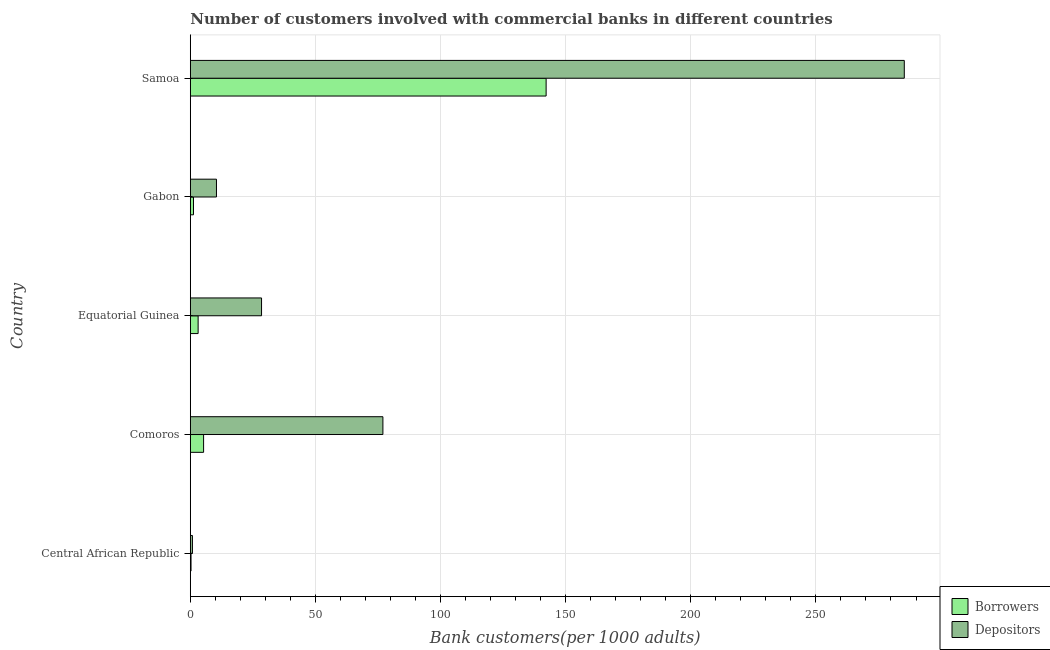Are the number of bars per tick equal to the number of legend labels?
Make the answer very short. Yes. Are the number of bars on each tick of the Y-axis equal?
Offer a very short reply. Yes. What is the label of the 1st group of bars from the top?
Give a very brief answer. Samoa. What is the number of depositors in Gabon?
Give a very brief answer. 10.46. Across all countries, what is the maximum number of borrowers?
Your response must be concise. 142.19. Across all countries, what is the minimum number of depositors?
Ensure brevity in your answer.  0.86. In which country was the number of depositors maximum?
Make the answer very short. Samoa. In which country was the number of depositors minimum?
Provide a short and direct response. Central African Republic. What is the total number of borrowers in the graph?
Offer a very short reply. 152.21. What is the difference between the number of borrowers in Central African Republic and that in Gabon?
Provide a succinct answer. -0.99. What is the difference between the number of borrowers in Central African Republic and the number of depositors in Gabon?
Ensure brevity in your answer.  -10.17. What is the average number of borrowers per country?
Provide a succinct answer. 30.44. What is the difference between the number of borrowers and number of depositors in Equatorial Guinea?
Ensure brevity in your answer.  -25.34. What is the difference between the highest and the second highest number of depositors?
Provide a short and direct response. 208.35. What is the difference between the highest and the lowest number of borrowers?
Give a very brief answer. 141.89. Is the sum of the number of depositors in Gabon and Samoa greater than the maximum number of borrowers across all countries?
Ensure brevity in your answer.  Yes. What does the 1st bar from the top in Comoros represents?
Provide a short and direct response. Depositors. What does the 2nd bar from the bottom in Gabon represents?
Give a very brief answer. Depositors. How many countries are there in the graph?
Keep it short and to the point. 5. What is the difference between two consecutive major ticks on the X-axis?
Offer a very short reply. 50. Are the values on the major ticks of X-axis written in scientific E-notation?
Keep it short and to the point. No. Does the graph contain any zero values?
Ensure brevity in your answer.  No. Where does the legend appear in the graph?
Make the answer very short. Bottom right. How are the legend labels stacked?
Make the answer very short. Vertical. What is the title of the graph?
Your response must be concise. Number of customers involved with commercial banks in different countries. What is the label or title of the X-axis?
Ensure brevity in your answer.  Bank customers(per 1000 adults). What is the label or title of the Y-axis?
Make the answer very short. Country. What is the Bank customers(per 1000 adults) in Borrowers in Central African Republic?
Give a very brief answer. 0.3. What is the Bank customers(per 1000 adults) of Depositors in Central African Republic?
Ensure brevity in your answer.  0.86. What is the Bank customers(per 1000 adults) of Borrowers in Comoros?
Offer a very short reply. 5.31. What is the Bank customers(per 1000 adults) in Depositors in Comoros?
Provide a short and direct response. 76.97. What is the Bank customers(per 1000 adults) in Borrowers in Equatorial Guinea?
Offer a terse response. 3.13. What is the Bank customers(per 1000 adults) in Depositors in Equatorial Guinea?
Ensure brevity in your answer.  28.47. What is the Bank customers(per 1000 adults) in Borrowers in Gabon?
Offer a terse response. 1.28. What is the Bank customers(per 1000 adults) of Depositors in Gabon?
Your answer should be very brief. 10.46. What is the Bank customers(per 1000 adults) of Borrowers in Samoa?
Your answer should be very brief. 142.19. What is the Bank customers(per 1000 adults) of Depositors in Samoa?
Your response must be concise. 285.32. Across all countries, what is the maximum Bank customers(per 1000 adults) of Borrowers?
Make the answer very short. 142.19. Across all countries, what is the maximum Bank customers(per 1000 adults) in Depositors?
Offer a terse response. 285.32. Across all countries, what is the minimum Bank customers(per 1000 adults) in Borrowers?
Offer a terse response. 0.3. Across all countries, what is the minimum Bank customers(per 1000 adults) in Depositors?
Your answer should be compact. 0.86. What is the total Bank customers(per 1000 adults) of Borrowers in the graph?
Your answer should be very brief. 152.21. What is the total Bank customers(per 1000 adults) of Depositors in the graph?
Provide a short and direct response. 402.08. What is the difference between the Bank customers(per 1000 adults) in Borrowers in Central African Republic and that in Comoros?
Offer a terse response. -5.02. What is the difference between the Bank customers(per 1000 adults) of Depositors in Central African Republic and that in Comoros?
Provide a succinct answer. -76.11. What is the difference between the Bank customers(per 1000 adults) of Borrowers in Central African Republic and that in Equatorial Guinea?
Provide a short and direct response. -2.84. What is the difference between the Bank customers(per 1000 adults) of Depositors in Central African Republic and that in Equatorial Guinea?
Provide a succinct answer. -27.62. What is the difference between the Bank customers(per 1000 adults) in Borrowers in Central African Republic and that in Gabon?
Your response must be concise. -0.99. What is the difference between the Bank customers(per 1000 adults) in Depositors in Central African Republic and that in Gabon?
Keep it short and to the point. -9.61. What is the difference between the Bank customers(per 1000 adults) of Borrowers in Central African Republic and that in Samoa?
Provide a short and direct response. -141.89. What is the difference between the Bank customers(per 1000 adults) in Depositors in Central African Republic and that in Samoa?
Offer a terse response. -284.46. What is the difference between the Bank customers(per 1000 adults) in Borrowers in Comoros and that in Equatorial Guinea?
Offer a terse response. 2.18. What is the difference between the Bank customers(per 1000 adults) of Depositors in Comoros and that in Equatorial Guinea?
Make the answer very short. 48.5. What is the difference between the Bank customers(per 1000 adults) in Borrowers in Comoros and that in Gabon?
Provide a short and direct response. 4.03. What is the difference between the Bank customers(per 1000 adults) in Depositors in Comoros and that in Gabon?
Your answer should be compact. 66.51. What is the difference between the Bank customers(per 1000 adults) of Borrowers in Comoros and that in Samoa?
Ensure brevity in your answer.  -136.88. What is the difference between the Bank customers(per 1000 adults) in Depositors in Comoros and that in Samoa?
Your answer should be very brief. -208.35. What is the difference between the Bank customers(per 1000 adults) in Borrowers in Equatorial Guinea and that in Gabon?
Your response must be concise. 1.85. What is the difference between the Bank customers(per 1000 adults) of Depositors in Equatorial Guinea and that in Gabon?
Keep it short and to the point. 18.01. What is the difference between the Bank customers(per 1000 adults) in Borrowers in Equatorial Guinea and that in Samoa?
Provide a succinct answer. -139.06. What is the difference between the Bank customers(per 1000 adults) in Depositors in Equatorial Guinea and that in Samoa?
Make the answer very short. -256.85. What is the difference between the Bank customers(per 1000 adults) in Borrowers in Gabon and that in Samoa?
Keep it short and to the point. -140.91. What is the difference between the Bank customers(per 1000 adults) of Depositors in Gabon and that in Samoa?
Your response must be concise. -274.86. What is the difference between the Bank customers(per 1000 adults) in Borrowers in Central African Republic and the Bank customers(per 1000 adults) in Depositors in Comoros?
Provide a short and direct response. -76.68. What is the difference between the Bank customers(per 1000 adults) in Borrowers in Central African Republic and the Bank customers(per 1000 adults) in Depositors in Equatorial Guinea?
Offer a terse response. -28.18. What is the difference between the Bank customers(per 1000 adults) of Borrowers in Central African Republic and the Bank customers(per 1000 adults) of Depositors in Gabon?
Offer a very short reply. -10.17. What is the difference between the Bank customers(per 1000 adults) in Borrowers in Central African Republic and the Bank customers(per 1000 adults) in Depositors in Samoa?
Keep it short and to the point. -285.02. What is the difference between the Bank customers(per 1000 adults) in Borrowers in Comoros and the Bank customers(per 1000 adults) in Depositors in Equatorial Guinea?
Make the answer very short. -23.16. What is the difference between the Bank customers(per 1000 adults) of Borrowers in Comoros and the Bank customers(per 1000 adults) of Depositors in Gabon?
Offer a terse response. -5.15. What is the difference between the Bank customers(per 1000 adults) of Borrowers in Comoros and the Bank customers(per 1000 adults) of Depositors in Samoa?
Provide a short and direct response. -280.01. What is the difference between the Bank customers(per 1000 adults) of Borrowers in Equatorial Guinea and the Bank customers(per 1000 adults) of Depositors in Gabon?
Ensure brevity in your answer.  -7.33. What is the difference between the Bank customers(per 1000 adults) of Borrowers in Equatorial Guinea and the Bank customers(per 1000 adults) of Depositors in Samoa?
Your answer should be compact. -282.19. What is the difference between the Bank customers(per 1000 adults) of Borrowers in Gabon and the Bank customers(per 1000 adults) of Depositors in Samoa?
Offer a terse response. -284.04. What is the average Bank customers(per 1000 adults) in Borrowers per country?
Your answer should be very brief. 30.44. What is the average Bank customers(per 1000 adults) of Depositors per country?
Offer a very short reply. 80.42. What is the difference between the Bank customers(per 1000 adults) in Borrowers and Bank customers(per 1000 adults) in Depositors in Central African Republic?
Make the answer very short. -0.56. What is the difference between the Bank customers(per 1000 adults) of Borrowers and Bank customers(per 1000 adults) of Depositors in Comoros?
Provide a short and direct response. -71.66. What is the difference between the Bank customers(per 1000 adults) in Borrowers and Bank customers(per 1000 adults) in Depositors in Equatorial Guinea?
Your answer should be very brief. -25.34. What is the difference between the Bank customers(per 1000 adults) in Borrowers and Bank customers(per 1000 adults) in Depositors in Gabon?
Make the answer very short. -9.18. What is the difference between the Bank customers(per 1000 adults) of Borrowers and Bank customers(per 1000 adults) of Depositors in Samoa?
Offer a very short reply. -143.13. What is the ratio of the Bank customers(per 1000 adults) of Borrowers in Central African Republic to that in Comoros?
Provide a short and direct response. 0.06. What is the ratio of the Bank customers(per 1000 adults) in Depositors in Central African Republic to that in Comoros?
Give a very brief answer. 0.01. What is the ratio of the Bank customers(per 1000 adults) in Borrowers in Central African Republic to that in Equatorial Guinea?
Give a very brief answer. 0.09. What is the ratio of the Bank customers(per 1000 adults) in Depositors in Central African Republic to that in Equatorial Guinea?
Provide a succinct answer. 0.03. What is the ratio of the Bank customers(per 1000 adults) in Borrowers in Central African Republic to that in Gabon?
Your answer should be very brief. 0.23. What is the ratio of the Bank customers(per 1000 adults) in Depositors in Central African Republic to that in Gabon?
Provide a succinct answer. 0.08. What is the ratio of the Bank customers(per 1000 adults) of Borrowers in Central African Republic to that in Samoa?
Offer a terse response. 0. What is the ratio of the Bank customers(per 1000 adults) in Depositors in Central African Republic to that in Samoa?
Give a very brief answer. 0. What is the ratio of the Bank customers(per 1000 adults) of Borrowers in Comoros to that in Equatorial Guinea?
Offer a very short reply. 1.7. What is the ratio of the Bank customers(per 1000 adults) of Depositors in Comoros to that in Equatorial Guinea?
Your answer should be compact. 2.7. What is the ratio of the Bank customers(per 1000 adults) in Borrowers in Comoros to that in Gabon?
Your answer should be compact. 4.14. What is the ratio of the Bank customers(per 1000 adults) of Depositors in Comoros to that in Gabon?
Ensure brevity in your answer.  7.36. What is the ratio of the Bank customers(per 1000 adults) of Borrowers in Comoros to that in Samoa?
Your answer should be very brief. 0.04. What is the ratio of the Bank customers(per 1000 adults) of Depositors in Comoros to that in Samoa?
Keep it short and to the point. 0.27. What is the ratio of the Bank customers(per 1000 adults) in Borrowers in Equatorial Guinea to that in Gabon?
Your response must be concise. 2.44. What is the ratio of the Bank customers(per 1000 adults) of Depositors in Equatorial Guinea to that in Gabon?
Offer a terse response. 2.72. What is the ratio of the Bank customers(per 1000 adults) of Borrowers in Equatorial Guinea to that in Samoa?
Provide a short and direct response. 0.02. What is the ratio of the Bank customers(per 1000 adults) of Depositors in Equatorial Guinea to that in Samoa?
Keep it short and to the point. 0.1. What is the ratio of the Bank customers(per 1000 adults) in Borrowers in Gabon to that in Samoa?
Offer a very short reply. 0.01. What is the ratio of the Bank customers(per 1000 adults) in Depositors in Gabon to that in Samoa?
Your response must be concise. 0.04. What is the difference between the highest and the second highest Bank customers(per 1000 adults) in Borrowers?
Offer a very short reply. 136.88. What is the difference between the highest and the second highest Bank customers(per 1000 adults) of Depositors?
Provide a succinct answer. 208.35. What is the difference between the highest and the lowest Bank customers(per 1000 adults) in Borrowers?
Your answer should be compact. 141.89. What is the difference between the highest and the lowest Bank customers(per 1000 adults) of Depositors?
Your response must be concise. 284.46. 